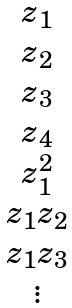Convert formula to latex. <formula><loc_0><loc_0><loc_500><loc_500>\begin{matrix} z _ { 1 } \\ z _ { 2 } \\ z _ { 3 } \\ z _ { 4 } \\ z _ { 1 } ^ { 2 } \\ z _ { 1 } z _ { 2 } \\ z _ { 1 } z _ { 3 } \\ \vdots \end{matrix}</formula> 